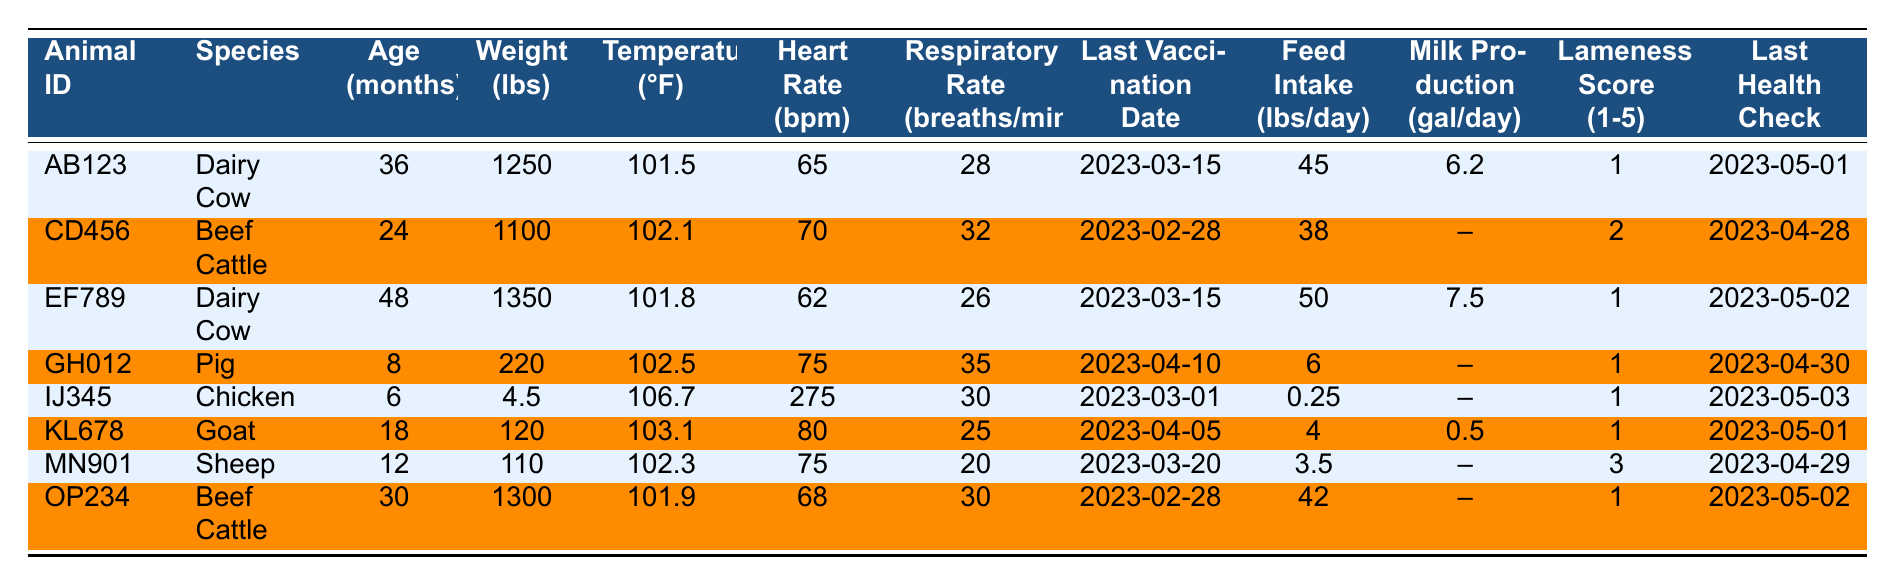What is the weight of the Dairy Cow with Animal ID AB123? The table lists AB123 as a Dairy Cow, and the corresponding weight is directly provided in the table as 1250 lbs.
Answer: 1250 lbs What is the respiratory rate of the Pig with Animal ID GH012? The table shows that the respiratory rate for the Pig with ID GH012 is listed as 35 breaths/min.
Answer: 35 breaths/min What is the lameness score for the Chicken with Animal ID IJ345? According to the table, the lameness score for the Chicken with ID IJ345 is noted as 1.
Answer: 1 What is the average weight of all the animals in the table? The weights of the animals are 1250, 1100, 1350, 220, 4.5, 120, 110, and 1300 lbs. The total weight is 1250 + 1100 + 1350 + 220 + 4.5 + 120 + 110 + 1300 = 3564. There are 8 animals, so the average weight is 3564 / 8 = 445.5 lbs.
Answer: 445.5 lbs How many animals have a lameness score greater than 1? Checking the table, the lameness scores are 1, 2, 1, 1, 1, 3, and 1. Only 1 animal, MN901, has a score greater than 1.
Answer: 1 Is there any animal that has a milk production value listed? The table shows that the Dairy Cows AB123 and EF789 both have milk production values of 6.2 and 7.5 gallons/day, respectively. Therefore, yes, there are animals with listed milk production values.
Answer: Yes What is the temperature of the Goat with Animal ID KL678 and how does it compare to the Pig with Animal ID GH012? The Goat KL678 has a temperature of 103.1°F and the Pig GH012 has a temperature of 102.5°F. The Goat's temperature is higher than the Pig's temperature by 0.6°F (103.1 - 102.5 = 0.6).
Answer: 103.1°F, higher by 0.6°F What is the total feed intake of all Beef Cattle in the table? The Beef Cattle are CD456 (38 lbs), and OP234 (42 lbs). Adding these gives a total feed intake of 38 + 42 = 80 lbs/day for all Beef Cattle.
Answer: 80 lbs/day What are the species of the animals that had their last health check after April 30, 2023? Referring to the Last Health Check column, only the entries for AB123 and EF789 list dates after April 30, which are May 1 and May 2. They are both Dairy Cows.
Answer: Dairy Cow Which animal had the last health check and what was that date? Among all animals, the latest Last Health Check date is for the Dairy Cow EF789 on May 2, 2023.
Answer: May 2, 2023 